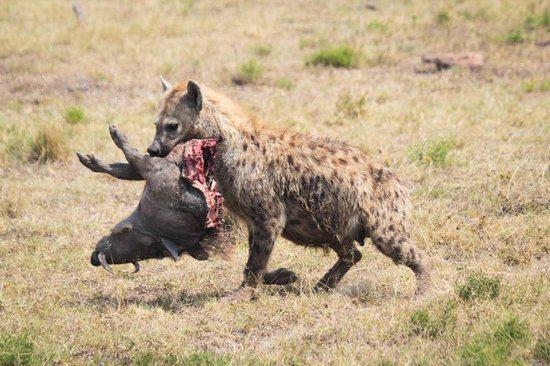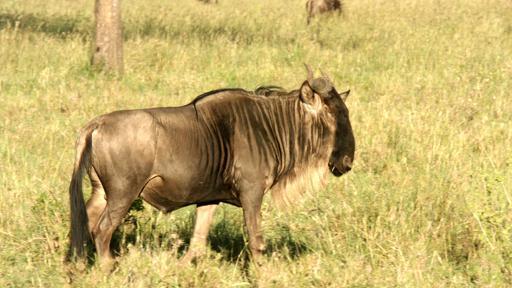The first image is the image on the left, the second image is the image on the right. Assess this claim about the two images: "There is exactly one hyena.". Correct or not? Answer yes or no. Yes. The first image is the image on the left, the second image is the image on the right. Considering the images on both sides, is "An animal is laying bleeding in the image on the right." valid? Answer yes or no. No. 